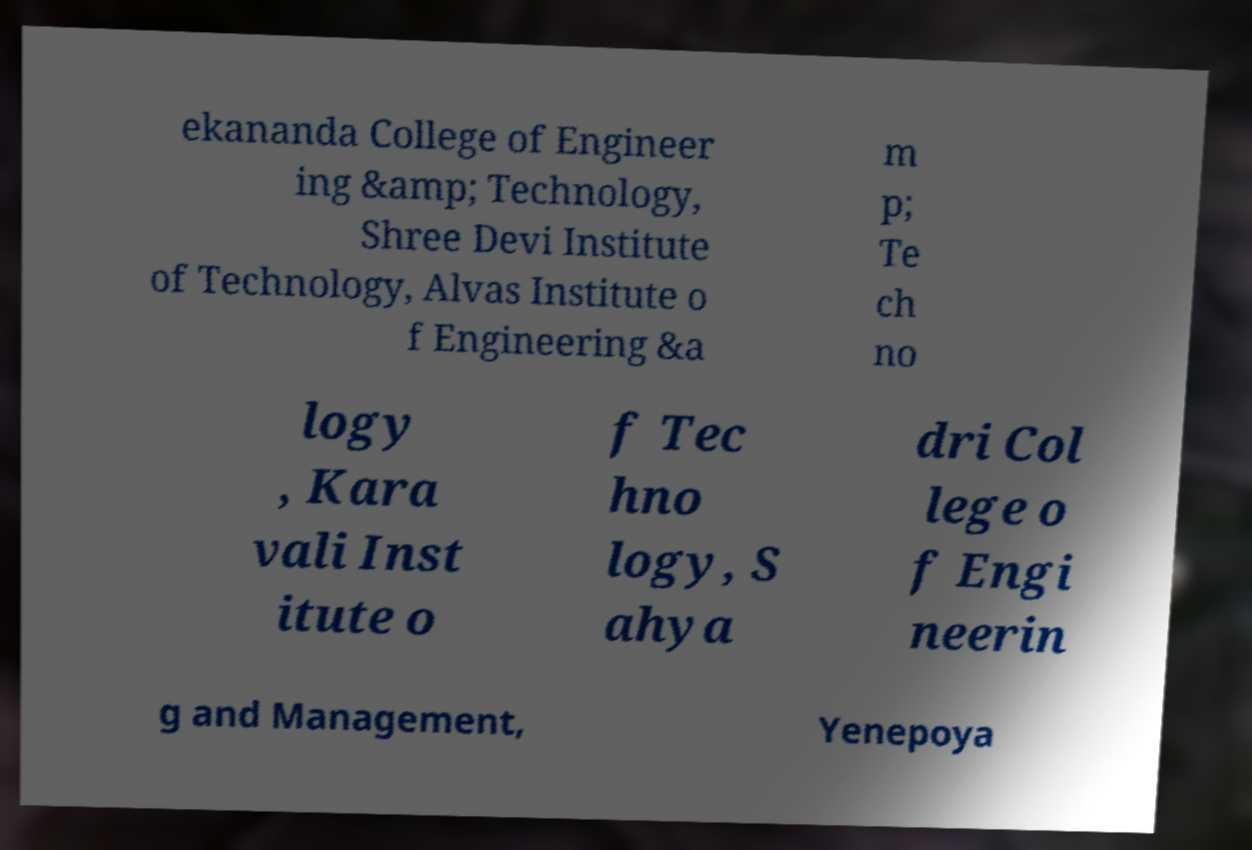Please read and relay the text visible in this image. What does it say? ekananda College of Engineer ing &amp; Technology, Shree Devi Institute of Technology, Alvas Institute o f Engineering &a m p; Te ch no logy , Kara vali Inst itute o f Tec hno logy, S ahya dri Col lege o f Engi neerin g and Management, Yenepoya 